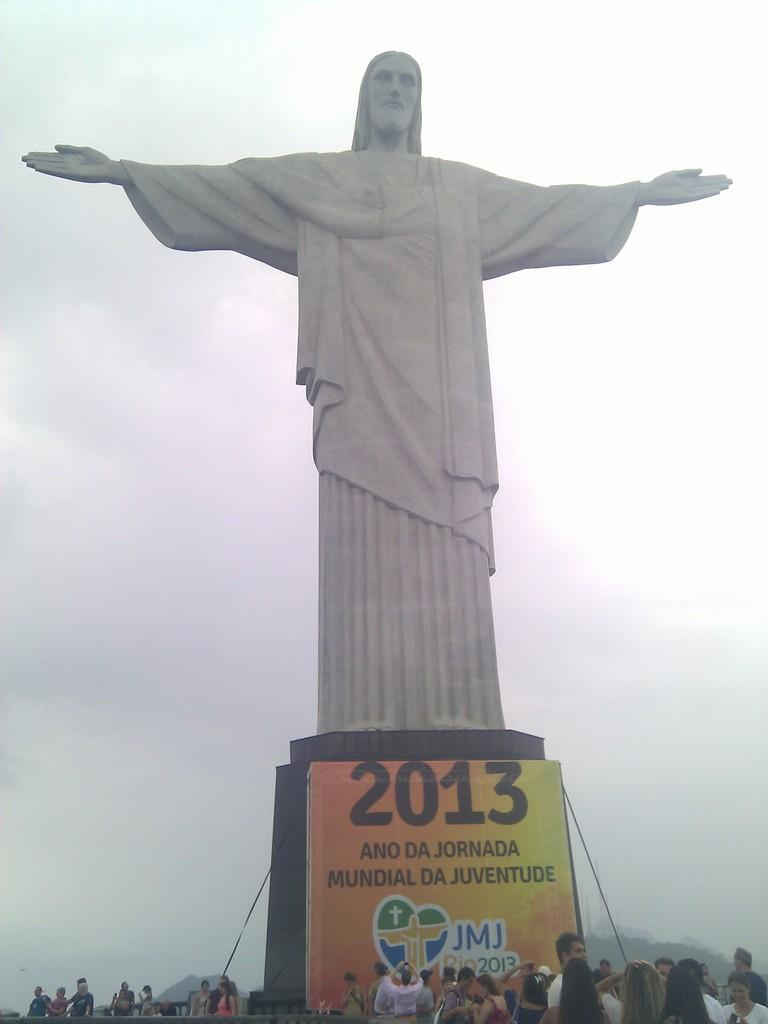<image>
Offer a succinct explanation of the picture presented. A large statue of Jesus sits high above a crowd of people with a banner that says 2013. 